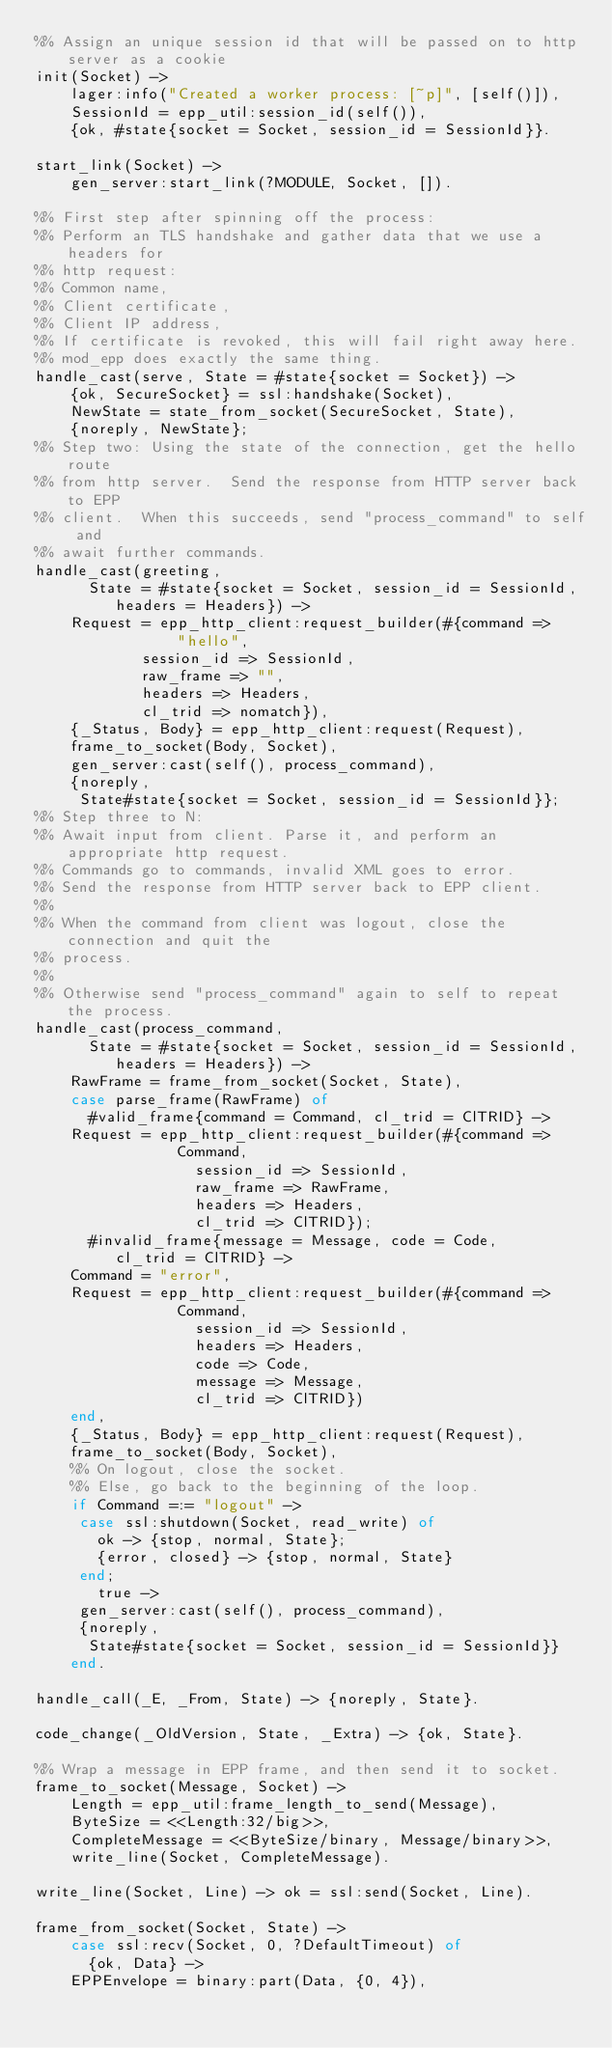Convert code to text. <code><loc_0><loc_0><loc_500><loc_500><_Erlang_>%% Assign an unique session id that will be passed on to http server as a cookie
init(Socket) ->
    lager:info("Created a worker process: [~p]", [self()]),
    SessionId = epp_util:session_id(self()),
    {ok, #state{socket = Socket, session_id = SessionId}}.

start_link(Socket) ->
    gen_server:start_link(?MODULE, Socket, []).

%% First step after spinning off the process:
%% Perform an TLS handshake and gather data that we use a headers for
%% http request:
%% Common name,
%% Client certificate,
%% Client IP address,
%% If certificate is revoked, this will fail right away here.
%% mod_epp does exactly the same thing.
handle_cast(serve, State = #state{socket = Socket}) ->
    {ok, SecureSocket} = ssl:handshake(Socket),
    NewState = state_from_socket(SecureSocket, State),
    {noreply, NewState};
%% Step two: Using the state of the connection, get the hello route
%% from http server.  Send the response from HTTP server back to EPP
%% client.  When this succeeds, send "process_command" to self and
%% await further commands.
handle_cast(greeting,
	    State = #state{socket = Socket, session_id = SessionId,
			   headers = Headers}) ->
    Request = epp_http_client:request_builder(#{command =>
						    "hello",
						session_id => SessionId,
						raw_frame => "",
						headers => Headers,
						cl_trid => nomatch}),
    {_Status, Body} = epp_http_client:request(Request),
    frame_to_socket(Body, Socket),
    gen_server:cast(self(), process_command),
    {noreply,
     State#state{socket = Socket, session_id = SessionId}};
%% Step three to N:
%% Await input from client. Parse it, and perform an appropriate http request.
%% Commands go to commands, invalid XML goes to error.
%% Send the response from HTTP server back to EPP client.
%%
%% When the command from client was logout, close the connection and quit the
%% process.
%%
%% Otherwise send "process_command" again to self to repeat the process.
handle_cast(process_command,
	    State = #state{socket = Socket, session_id = SessionId,
			   headers = Headers}) ->
    RawFrame = frame_from_socket(Socket, State),
    case parse_frame(RawFrame) of
      #valid_frame{command = Command, cl_trid = ClTRID} ->
	  Request = epp_http_client:request_builder(#{command =>
							  Command,
						      session_id => SessionId,
						      raw_frame => RawFrame,
						      headers => Headers,
						      cl_trid => ClTRID});
      #invalid_frame{message = Message, code = Code,
		     cl_trid = ClTRID} ->
	  Command = "error",
	  Request = epp_http_client:request_builder(#{command =>
							  Command,
						      session_id => SessionId,
						      headers => Headers,
						      code => Code,
						      message => Message,
						      cl_trid => ClTRID})
    end,
    {_Status, Body} = epp_http_client:request(Request),
    frame_to_socket(Body, Socket),
    %% On logout, close the socket.
    %% Else, go back to the beginning of the loop.
    if Command =:= "logout" ->
	   case ssl:shutdown(Socket, read_write) of
	     ok -> {stop, normal, State};
	     {error, closed} -> {stop, normal, State}
	   end;
       true ->
	   gen_server:cast(self(), process_command),
	   {noreply,
	    State#state{socket = Socket, session_id = SessionId}}
    end.

handle_call(_E, _From, State) -> {noreply, State}.

code_change(_OldVersion, State, _Extra) -> {ok, State}.

%% Wrap a message in EPP frame, and then send it to socket.
frame_to_socket(Message, Socket) ->
    Length = epp_util:frame_length_to_send(Message),
    ByteSize = <<Length:32/big>>,
    CompleteMessage = <<ByteSize/binary, Message/binary>>,
    write_line(Socket, CompleteMessage).

write_line(Socket, Line) -> ok = ssl:send(Socket, Line).

frame_from_socket(Socket, State) ->
    case ssl:recv(Socket, 0, ?DefaultTimeout) of
      {ok, Data} ->
	  EPPEnvelope = binary:part(Data, {0, 4}),</code> 